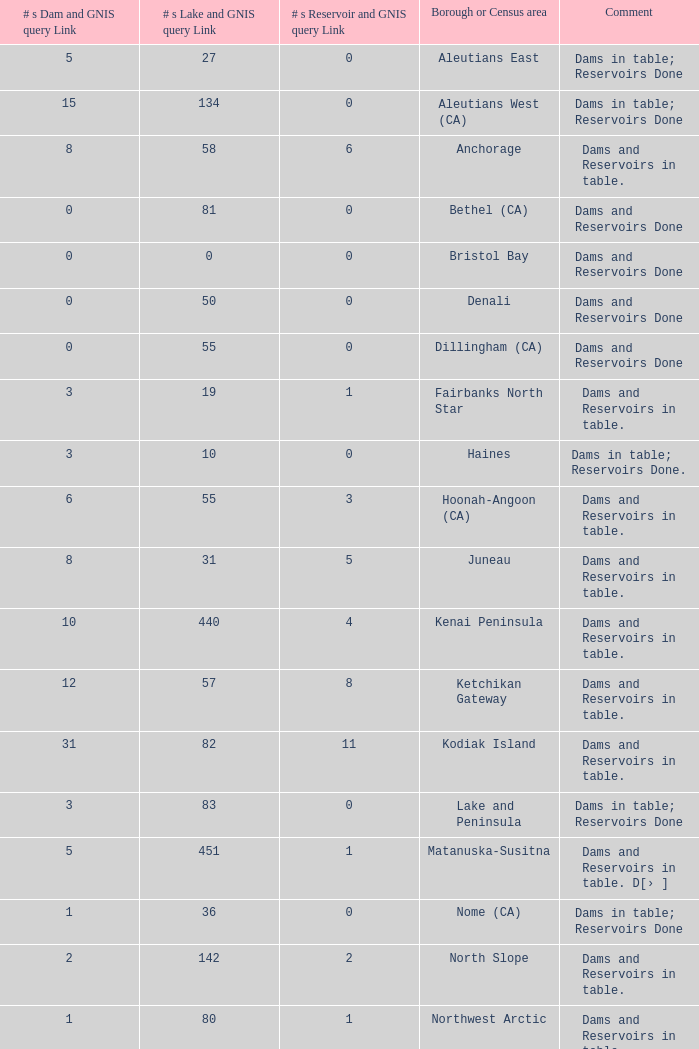Can you give me this table as a dict? {'header': ['# s Dam and GNIS query Link', '# s Lake and GNIS query Link', '# s Reservoir and GNIS query Link', 'Borough or Census area', 'Comment'], 'rows': [['5', '27', '0', 'Aleutians East', 'Dams in table; Reservoirs Done'], ['15', '134', '0', 'Aleutians West (CA)', 'Dams in table; Reservoirs Done'], ['8', '58', '6', 'Anchorage', 'Dams and Reservoirs in table.'], ['0', '81', '0', 'Bethel (CA)', 'Dams and Reservoirs Done'], ['0', '0', '0', 'Bristol Bay', 'Dams and Reservoirs Done'], ['0', '50', '0', 'Denali', 'Dams and Reservoirs Done'], ['0', '55', '0', 'Dillingham (CA)', 'Dams and Reservoirs Done'], ['3', '19', '1', 'Fairbanks North Star', 'Dams and Reservoirs in table.'], ['3', '10', '0', 'Haines', 'Dams in table; Reservoirs Done.'], ['6', '55', '3', 'Hoonah-Angoon (CA)', 'Dams and Reservoirs in table.'], ['8', '31', '5', 'Juneau', 'Dams and Reservoirs in table.'], ['10', '440', '4', 'Kenai Peninsula', 'Dams and Reservoirs in table.'], ['12', '57', '8', 'Ketchikan Gateway', 'Dams and Reservoirs in table.'], ['31', '82', '11', 'Kodiak Island', 'Dams and Reservoirs in table.'], ['3', '83', '0', 'Lake and Peninsula', 'Dams in table; Reservoirs Done'], ['5', '451', '1', 'Matanuska-Susitna', 'Dams and Reservoirs in table. D[› ]'], ['1', '36', '0', 'Nome (CA)', 'Dams in table; Reservoirs Done'], ['2', '142', '2', 'North Slope', 'Dams and Reservoirs in table.'], ['1', '80', '1', 'Northwest Arctic', 'Dams and Reservoirs in table.'], ['9', '163', '4', 'P. of Wales-O. Ketchikan (CA)', 'Dams and Reservoirs in table.'], ['9', '90', '3', 'Sitka', 'Dams and Reservoirs in table.'], ['3', '9', '3', 'Skagway', 'Dams and Reservoirs in table.'], ['0', '130', '0', 'Southeast Fairbanks (CA)', 'Dams and Reservoirs in table.'], ['22', '293', '10', 'Valdez-Cordova (CA)', 'Dams and Reservoirs in table.'], ['1', '21', '0', 'Wade Hampton (CA)', 'Dams in table; Reservoirs Done'], ['8', '60', '5', 'Wrangell-Petersburg (CA)', 'Dams and Reservoirs in table.'], ['0', '26', '0', 'Yakutat', 'Dams and Reservoirs Done'], ['2', '513', '0', 'Yukon-Koyukuk (CA)', 'Dams in table; Reservoirs Done']]} Identify the highest amount of dam and gnis query connections for borough or census region in fairbanks north star. 3.0. 